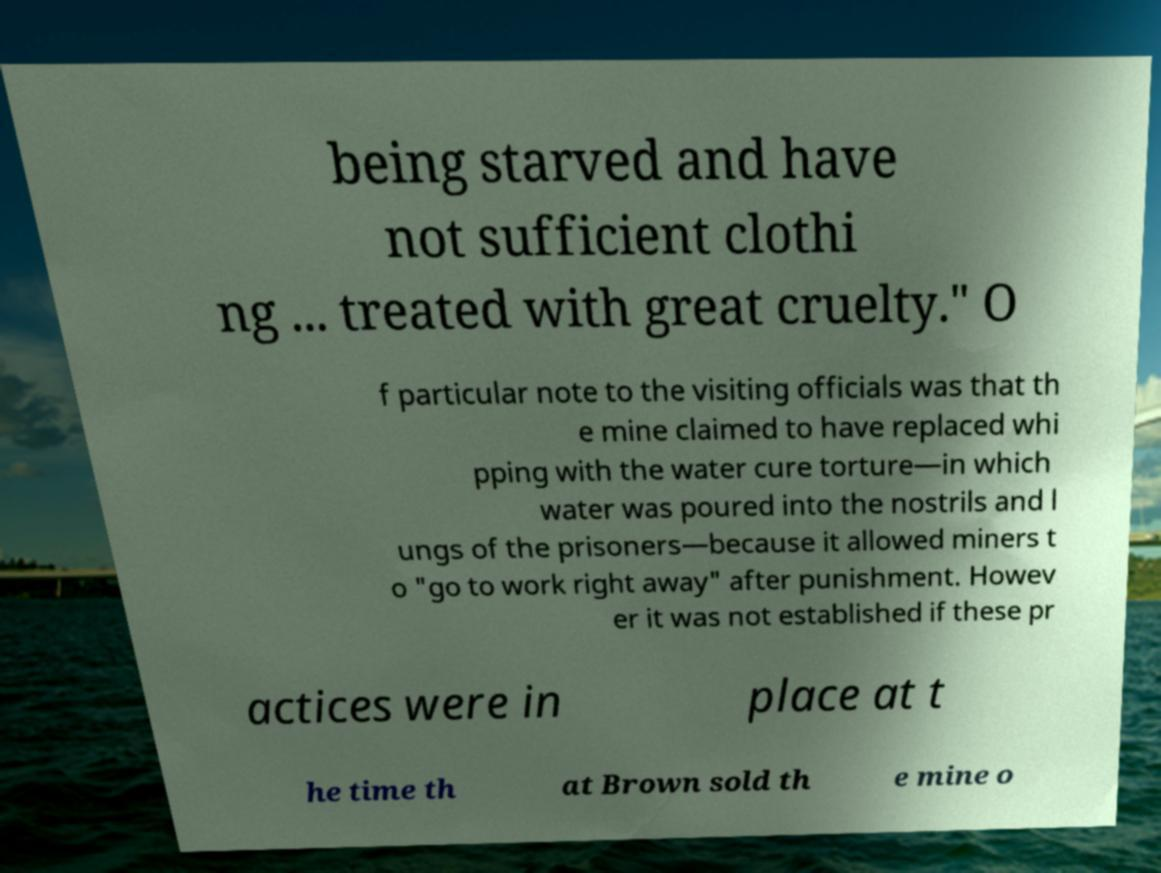What messages or text are displayed in this image? I need them in a readable, typed format. being starved and have not sufficient clothi ng ... treated with great cruelty." O f particular note to the visiting officials was that th e mine claimed to have replaced whi pping with the water cure torture—in which water was poured into the nostrils and l ungs of the prisoners—because it allowed miners t o "go to work right away" after punishment. Howev er it was not established if these pr actices were in place at t he time th at Brown sold th e mine o 